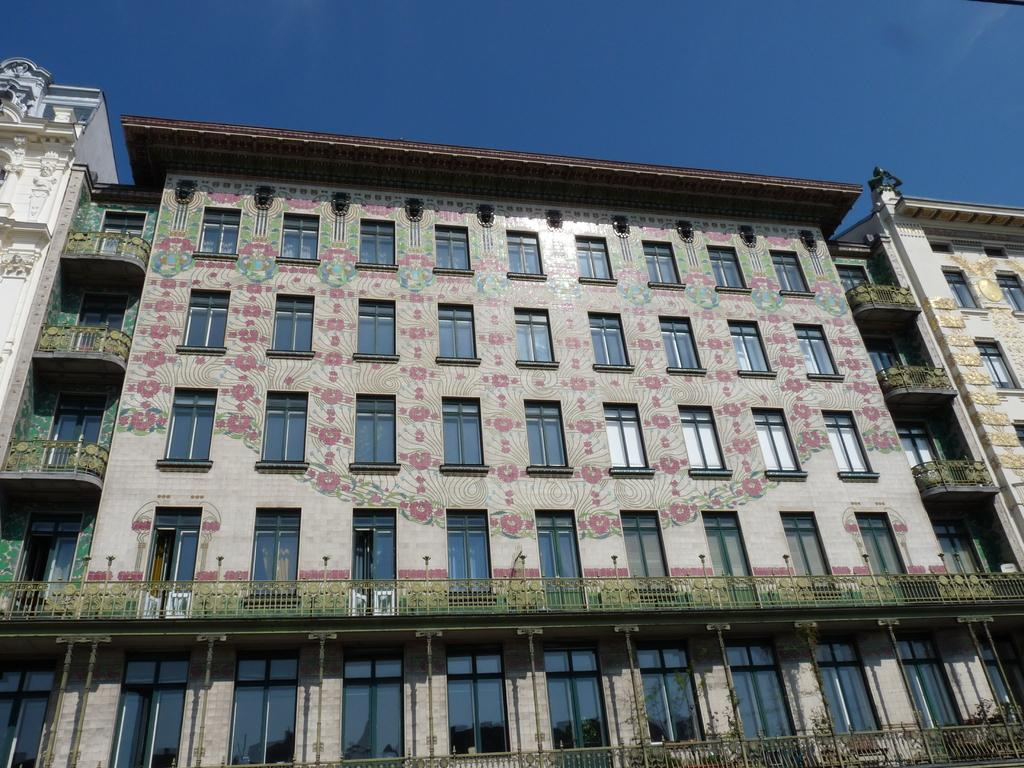What is the main subject of the image? The main subject of the image is a building. Can you describe the building in more detail? The building has multiple windows and designs on it. What can be seen in the background of the image? The sky is visible in the background of the image. How would you describe the sky in the image? The sky is clear in the image. What is the income of the giraffe standing next to the building in the image? There is no giraffe present in the image, so it is not possible to determine its income. 